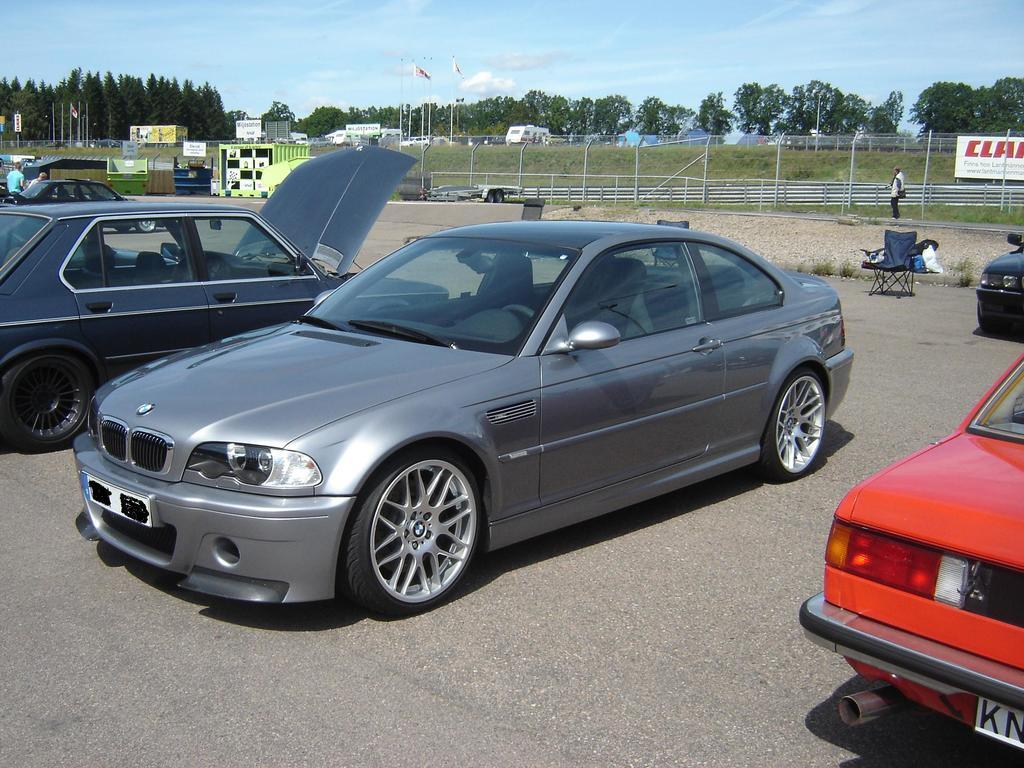What can be seen parked on the road in the image? There are vehicles parked on the road in the image. What type of furniture is present in the image? There is a chair in the image. What type of barrier can be seen in the image? There is a fence in the image. What type of signage is present in the image? There is a hoarding in the image. What type of decoration can be seen in the image? There are flags in the image. What type of vegetation is present in the image? There are trees in the image. What part of the natural environment is visible in the image? The sky is visible in the image. What type of weather can be inferred from the image? There are clouds in the sky, which suggests that the weather might be partly cloudy. What type of fog can be seen in the image? There is no fog present in the image. What type of downtown area is depicted in the image? The image does not depict a downtown area; it only shows vehicles parked on the road, a chair, a fence, a hoarding, flags, trees, the sky, and clouds. 